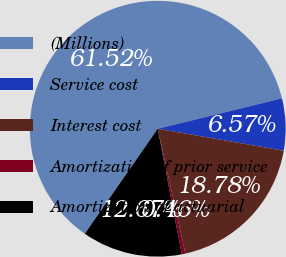Convert chart. <chart><loc_0><loc_0><loc_500><loc_500><pie_chart><fcel>(Millions)<fcel>Service cost<fcel>Interest cost<fcel>Amortization of prior service<fcel>Amortization of actuarial<nl><fcel>61.52%<fcel>6.57%<fcel>18.78%<fcel>0.46%<fcel>12.67%<nl></chart> 